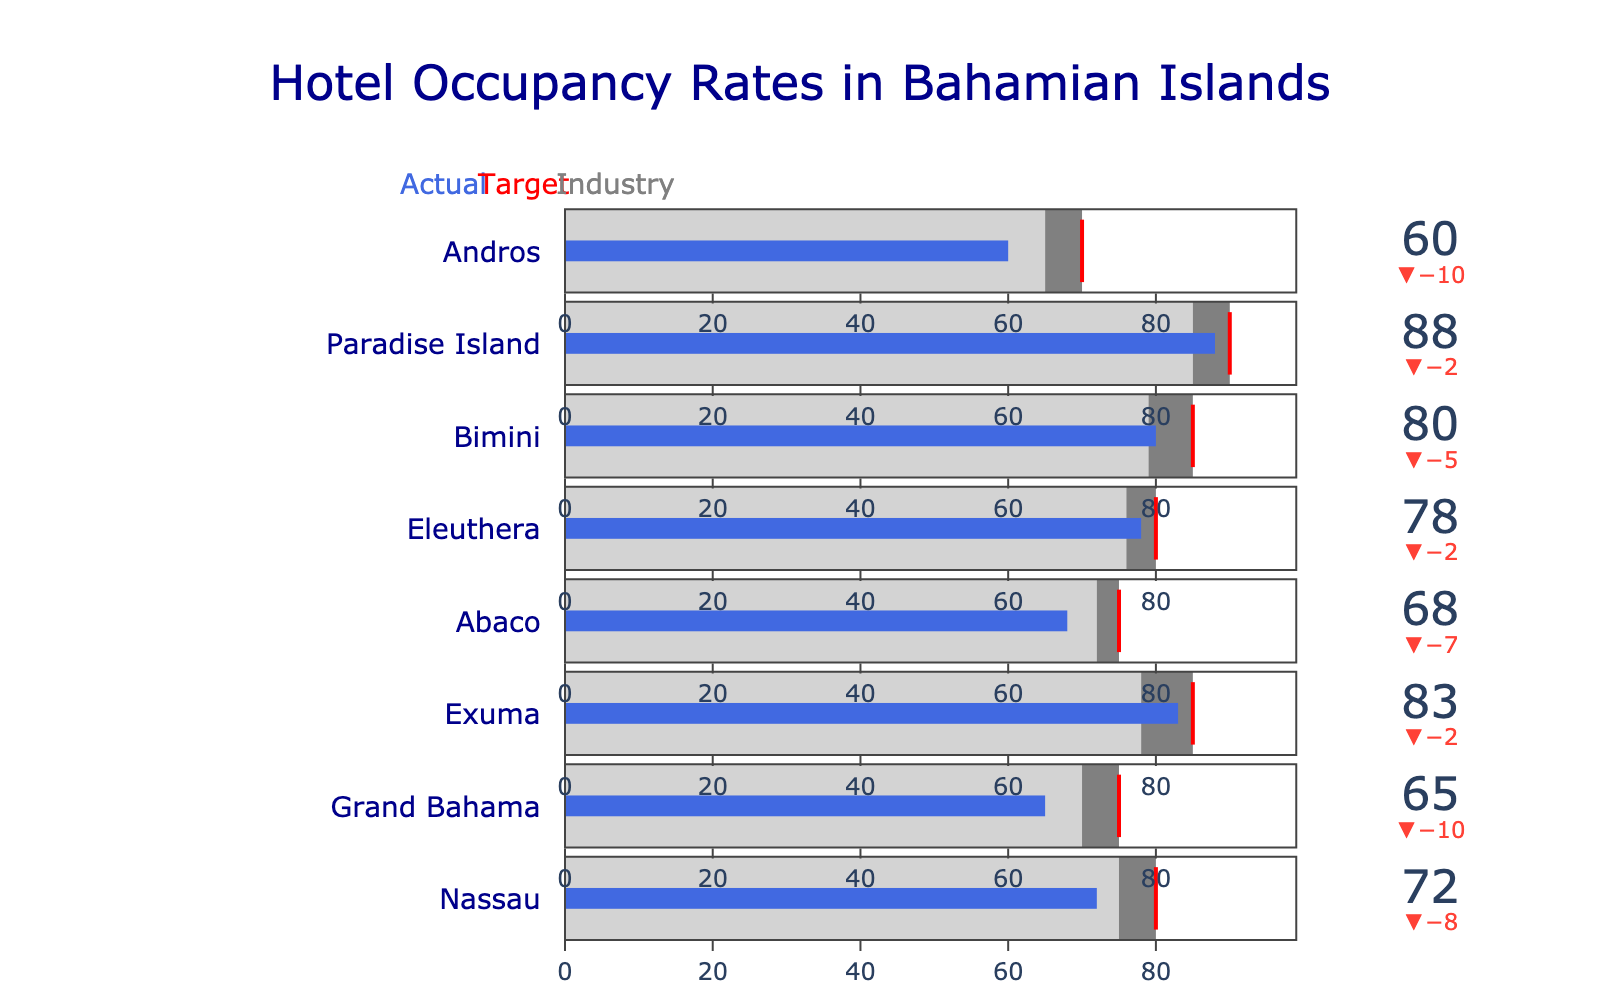what is the actual occupancy rate for Nassau? The figure directly lists the actual occupancy rate for each island on the bullet chart. For Nassau, the actual value is shown within the chart's blue bar.
Answer: 72 Which island has met its target occupancy rate? By observing the blue bars compared to the red target line for each island, only the blue bar for Paradise Island reaches the red target line.
Answer: Paradise Island What is the average target occupancy rate across all islands? Adding up all the target occupancy rates: 80 (Nassau) + 75 (Grand Bahama) + 85 (Exuma) + 75 (Abaco) + 80 (Eleuthera) + 85 (Bimini) + 90 (Paradise Island) + 70 (Andros) = 640. Dividing by the number of islands (8) gives the average: 640 / 8 = 80
Answer: 80 Which islands have an actual occupancy rate above the industry benchmark for their specific island? Comparing the actual rates to the industry benchmarks for each island: Nassau (72 < 75), Grand Bahama (65 < 70), Exuma (83 > 78), Abaco (68 < 72), Eleuthera (78 > 76), Bimini (80 > 79), Paradise Island (88 > 85), Andros (60 < 65).
Answer: Exuma, Eleuthera, Bimini, Paradise Island What is the difference between the actual and target occupancy rates for Exuma? The figure shows actual (83) and target (85) rates for Exuma. The difference is 85 - 83 = 2.
Answer: 2 How many islands have an actual occupancy rate below their industry benchmark? Comparing actual values to industry benchmarks: Nassau (72 < 75), Grand Bahama (65 < 70), Abaco (68 < 72), and Andros (60 < 65) all have actual rates below their benchmarks.
Answer: 4 By how much does Paradise Island's actual occupancy rate exceed its industry benchmark? The actual rate for Paradise Island is 88, and the industry benchmark is 85. The difference is 88 - 85 = 3.
Answer: 3 Which island has the lowest target occupancy rate? By examining the target occupancy rates for all islands, Andros has the lowest rate with 70.
Answer: Andros How does the actual occupancy rate of Abaco compare to Eleuthera? Abaco's actual occupancy rate is 68, while Eleuthera's is 78. 78 - 68 = 10, so Eleuthera's rate is higher by 10 points.
Answer: Eleuthera is higher by 10 points What is the combined actual occupancy rate for Nassau and Grand Bahama? Adding the actual rates: Nassau (72) + Grand Bahama (65) = 72 + 65 = 137
Answer: 137 